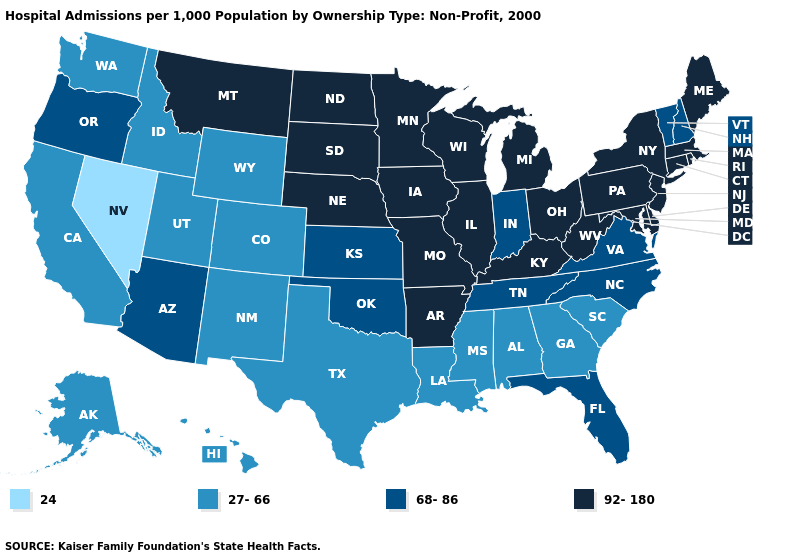Does the map have missing data?
Give a very brief answer. No. Which states have the lowest value in the USA?
Be succinct. Nevada. Name the states that have a value in the range 92-180?
Be succinct. Arkansas, Connecticut, Delaware, Illinois, Iowa, Kentucky, Maine, Maryland, Massachusetts, Michigan, Minnesota, Missouri, Montana, Nebraska, New Jersey, New York, North Dakota, Ohio, Pennsylvania, Rhode Island, South Dakota, West Virginia, Wisconsin. How many symbols are there in the legend?
Be succinct. 4. Does the first symbol in the legend represent the smallest category?
Quick response, please. Yes. Does Wyoming have a lower value than Utah?
Write a very short answer. No. Name the states that have a value in the range 27-66?
Concise answer only. Alabama, Alaska, California, Colorado, Georgia, Hawaii, Idaho, Louisiana, Mississippi, New Mexico, South Carolina, Texas, Utah, Washington, Wyoming. What is the value of Arkansas?
Give a very brief answer. 92-180. Does New Hampshire have the highest value in the USA?
Write a very short answer. No. What is the highest value in the West ?
Concise answer only. 92-180. Does the map have missing data?
Give a very brief answer. No. What is the lowest value in the USA?
Write a very short answer. 24. Which states have the highest value in the USA?
Be succinct. Arkansas, Connecticut, Delaware, Illinois, Iowa, Kentucky, Maine, Maryland, Massachusetts, Michigan, Minnesota, Missouri, Montana, Nebraska, New Jersey, New York, North Dakota, Ohio, Pennsylvania, Rhode Island, South Dakota, West Virginia, Wisconsin. What is the highest value in states that border Minnesota?
Answer briefly. 92-180. Among the states that border Tennessee , does North Carolina have the lowest value?
Quick response, please. No. 